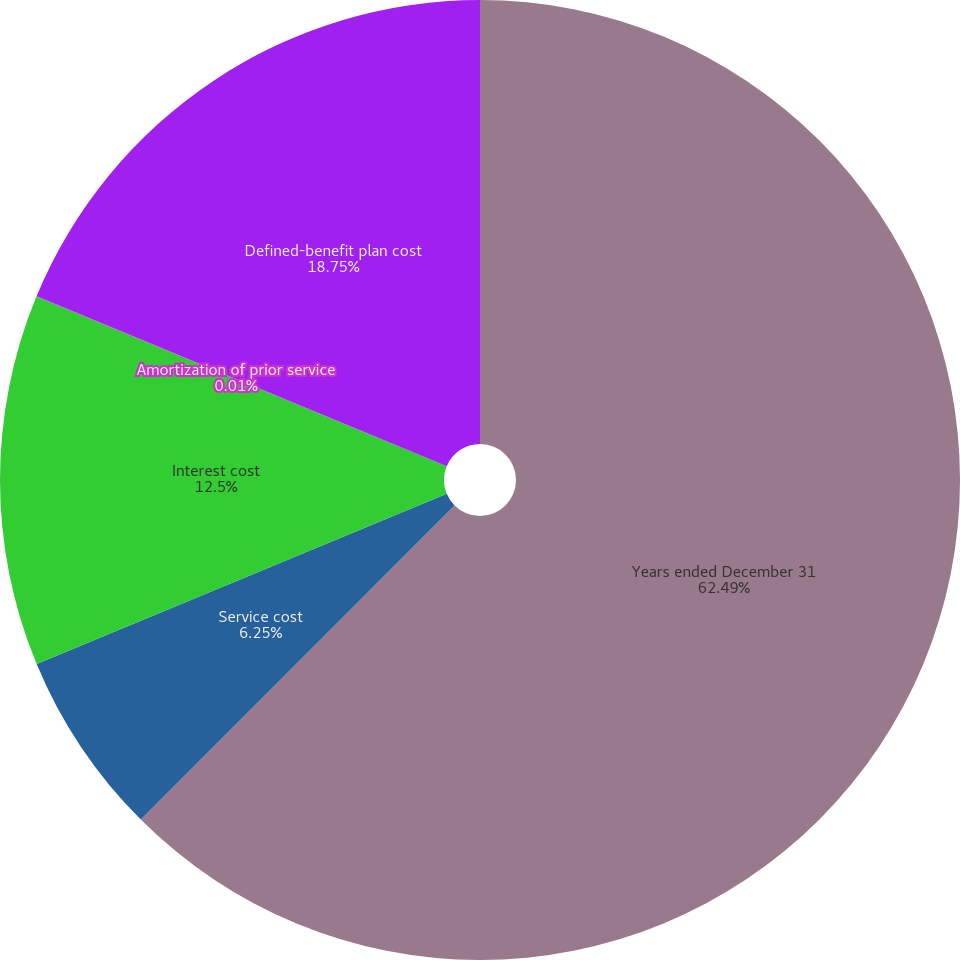<chart> <loc_0><loc_0><loc_500><loc_500><pie_chart><fcel>Years ended December 31<fcel>Service cost<fcel>Interest cost<fcel>Amortization of prior service<fcel>Defined-benefit plan cost<nl><fcel>62.49%<fcel>6.25%<fcel>12.5%<fcel>0.01%<fcel>18.75%<nl></chart> 